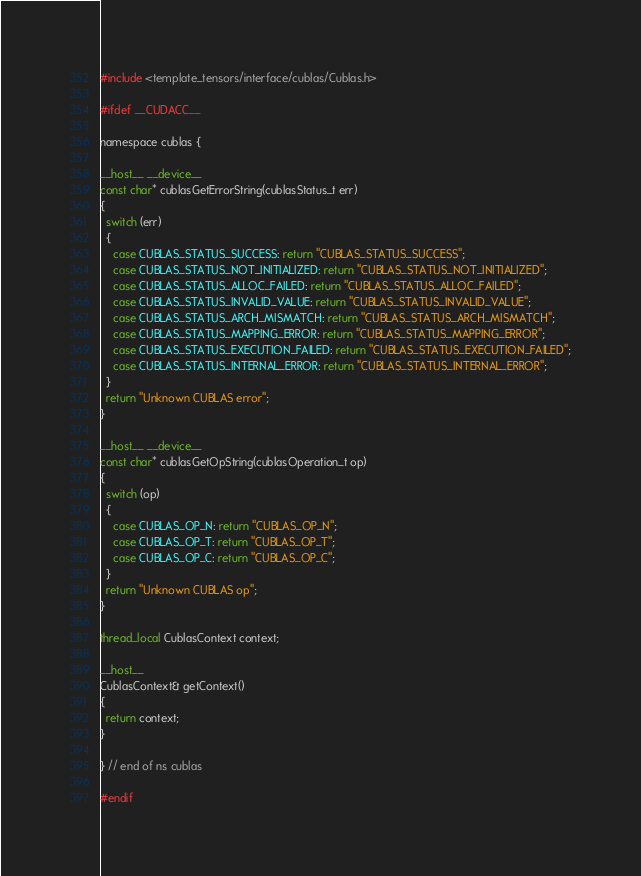Convert code to text. <code><loc_0><loc_0><loc_500><loc_500><_Cuda_>#include <template_tensors/interface/cublas/Cublas.h>

#ifdef __CUDACC__

namespace cublas {

__host__ __device__
const char* cublasGetErrorString(cublasStatus_t err)
{
  switch (err)
  {
    case CUBLAS_STATUS_SUCCESS: return "CUBLAS_STATUS_SUCCESS";
    case CUBLAS_STATUS_NOT_INITIALIZED: return "CUBLAS_STATUS_NOT_INITIALIZED";
    case CUBLAS_STATUS_ALLOC_FAILED: return "CUBLAS_STATUS_ALLOC_FAILED";
    case CUBLAS_STATUS_INVALID_VALUE: return "CUBLAS_STATUS_INVALID_VALUE";
    case CUBLAS_STATUS_ARCH_MISMATCH: return "CUBLAS_STATUS_ARCH_MISMATCH";
    case CUBLAS_STATUS_MAPPING_ERROR: return "CUBLAS_STATUS_MAPPING_ERROR";
    case CUBLAS_STATUS_EXECUTION_FAILED: return "CUBLAS_STATUS_EXECUTION_FAILED";
    case CUBLAS_STATUS_INTERNAL_ERROR: return "CUBLAS_STATUS_INTERNAL_ERROR";
  }
  return "Unknown CUBLAS error";
}

__host__ __device__
const char* cublasGetOpString(cublasOperation_t op)
{
  switch (op)
  {
    case CUBLAS_OP_N: return "CUBLAS_OP_N";
    case CUBLAS_OP_T: return "CUBLAS_OP_T";
    case CUBLAS_OP_C: return "CUBLAS_OP_C";
  }
  return "Unknown CUBLAS op";
}

thread_local CublasContext context;

__host__
CublasContext& getContext()
{
  return context;
}

} // end of ns cublas

#endif</code> 